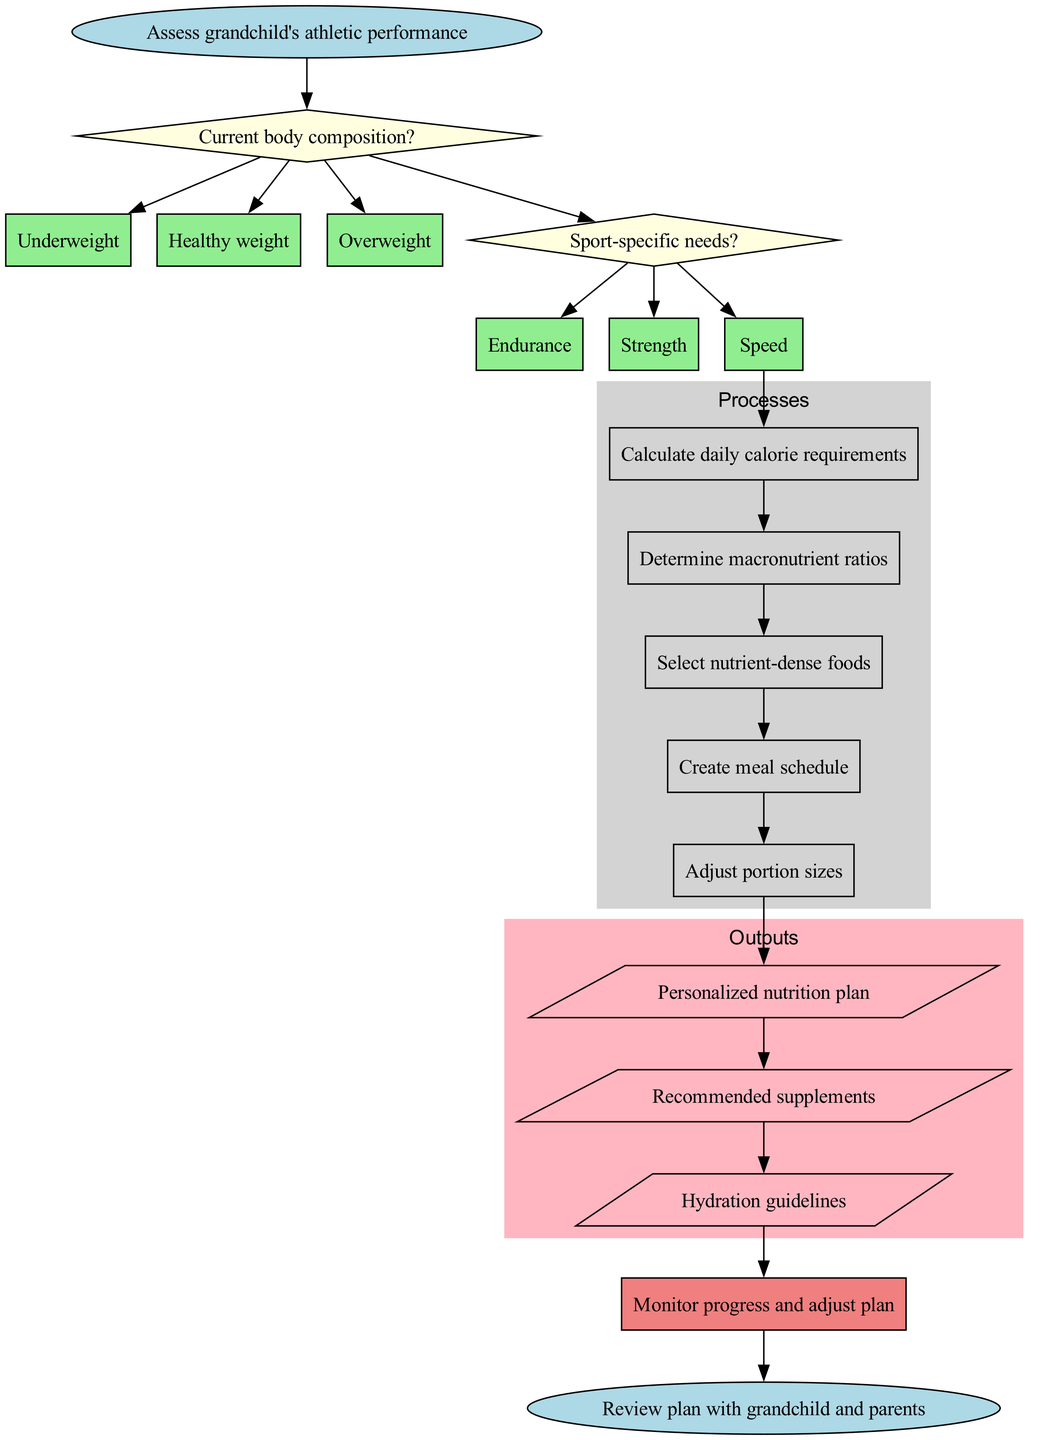What is the first node in the flowchart? The diagram begins with the 'start' node, which is labeled 'Assess grandchild's athletic performance'.
Answer: Assess grandchild's athletic performance How many decision nodes are present in the flowchart? There are two decision nodes, one for assessing body composition and the other for determining sport-specific needs.
Answer: 2 What is the last process in the flowchart? The last process listed in the flowchart is 'Adjust portion sizes'.
Answer: Adjust portion sizes What are the outputs of this flowchart? The flowchart includes three outputs: 'Personalized nutrition plan', 'Recommended supplements', and 'Hydration guidelines'.
Answer: Personalized nutrition plan, Recommended supplements, Hydration guidelines What connects the last decision node to the first process? The last decision node connects to the first process through the option selected from 'Sport-specific needs'.
Answer: Last decision option What is the feedback mechanism in this program? The feedback mechanism is 'Monitor progress and adjust plan', which allows for adjustments based on observed outcomes.
Answer: Monitor progress and adjust plan Which type of node is used for the final action in the flowchart? The final action is represented by an 'end' node, which is shaped like an ellipse, indicating the conclusion of the process.
Answer: End node Which two conditions are evaluated in the decision nodes? The decision nodes evaluate 'Current body composition' and 'Sport-specific needs'.
Answer: Current body composition, Sport-specific needs How many processes are outlined in the flowchart? There are five processes outlined in the flowchart, detailing the steps to create a nutrition plan.
Answer: 5 